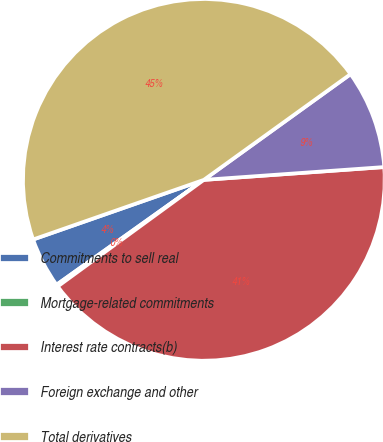<chart> <loc_0><loc_0><loc_500><loc_500><pie_chart><fcel>Commitments to sell real<fcel>Mortgage-related commitments<fcel>Interest rate contracts(b)<fcel>Foreign exchange and other<fcel>Total derivatives<nl><fcel>4.5%<fcel>0.18%<fcel>41.1%<fcel>8.81%<fcel>45.41%<nl></chart> 